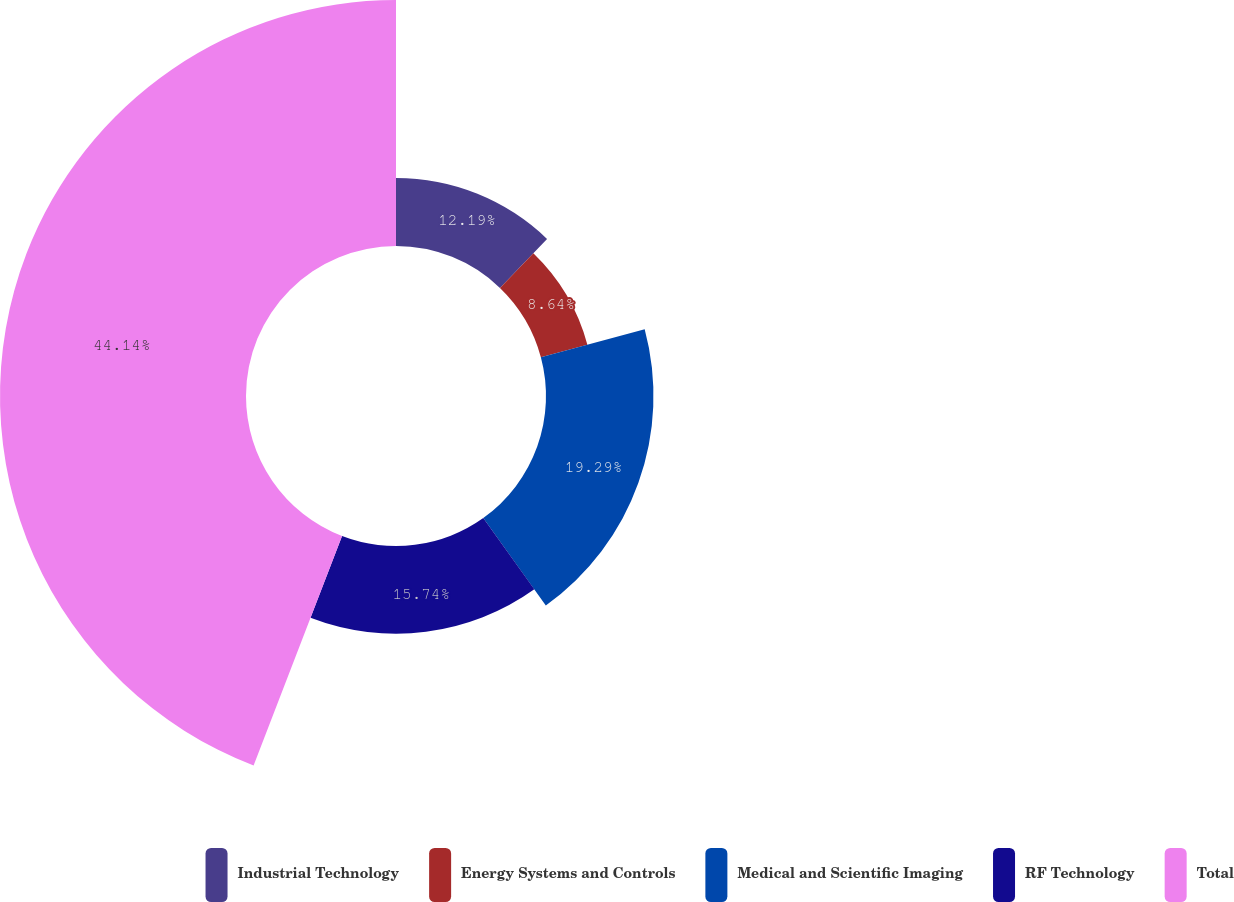Convert chart to OTSL. <chart><loc_0><loc_0><loc_500><loc_500><pie_chart><fcel>Industrial Technology<fcel>Energy Systems and Controls<fcel>Medical and Scientific Imaging<fcel>RF Technology<fcel>Total<nl><fcel>12.19%<fcel>8.64%<fcel>19.29%<fcel>15.74%<fcel>44.15%<nl></chart> 